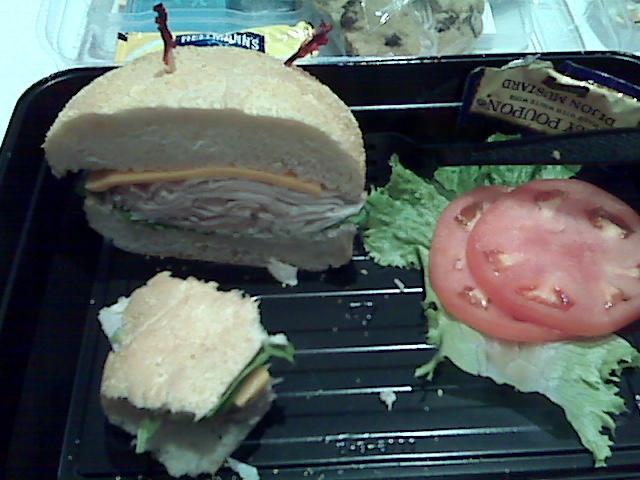What's available for dessert?
Short answer required. Cookie. What two vegetables are pictured?
Concise answer only. Lettuce and tomato. What's under the tomato?
Answer briefly. Lettuce. 